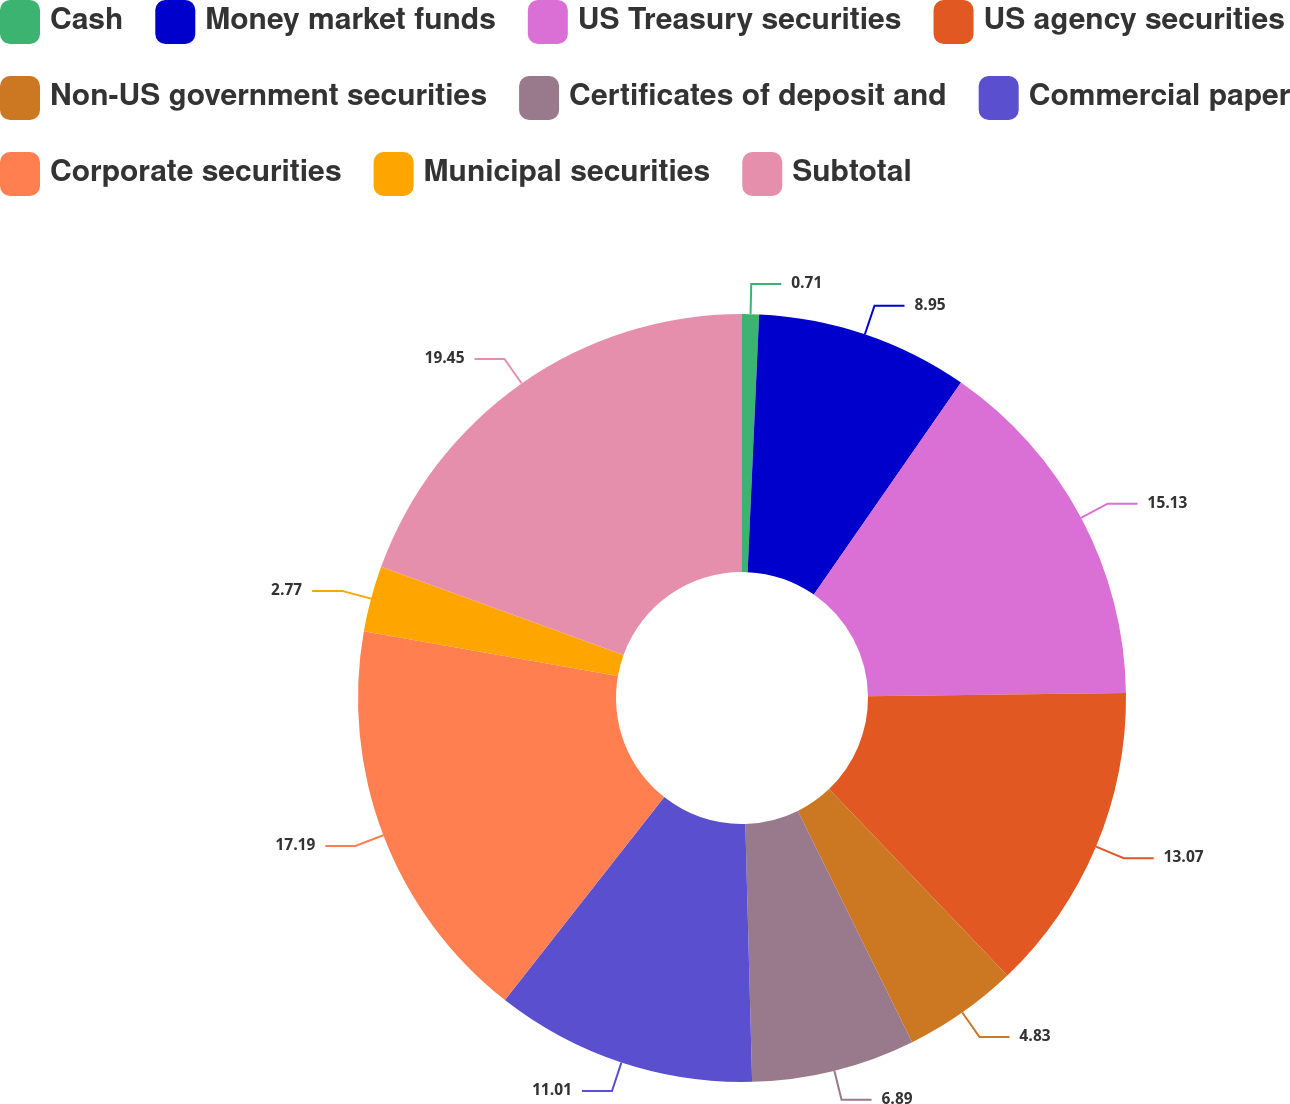Convert chart to OTSL. <chart><loc_0><loc_0><loc_500><loc_500><pie_chart><fcel>Cash<fcel>Money market funds<fcel>US Treasury securities<fcel>US agency securities<fcel>Non-US government securities<fcel>Certificates of deposit and<fcel>Commercial paper<fcel>Corporate securities<fcel>Municipal securities<fcel>Subtotal<nl><fcel>0.71%<fcel>8.95%<fcel>15.13%<fcel>13.07%<fcel>4.83%<fcel>6.89%<fcel>11.01%<fcel>17.19%<fcel>2.77%<fcel>19.45%<nl></chart> 